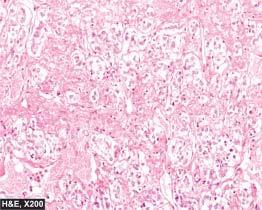does the tumour have typical zellballen or nested pattern?
Answer the question using a single word or phrase. Yes 